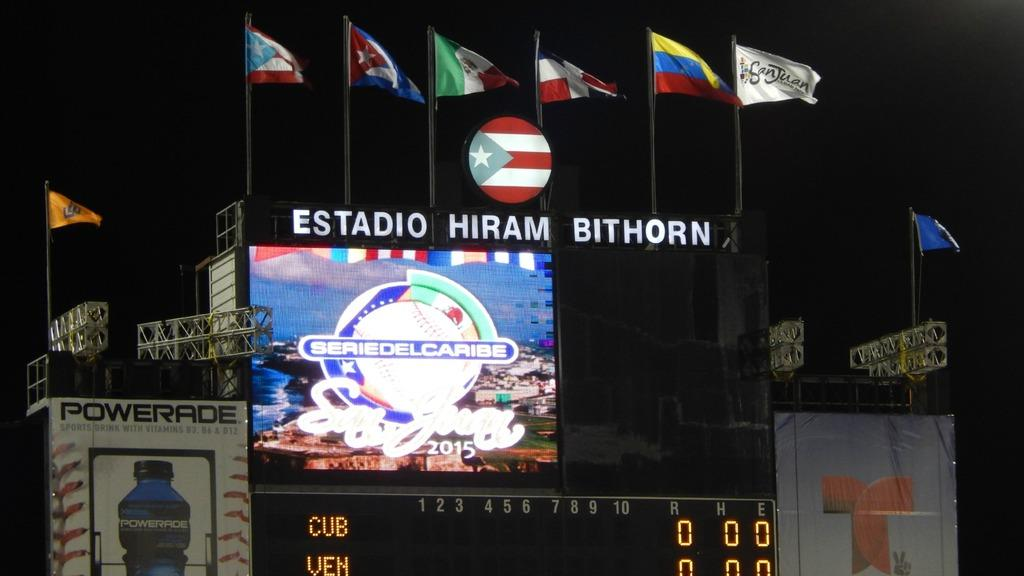<image>
Render a clear and concise summary of the photo. a sign above a scoreboard that says 'estadio hiram bithorn' 